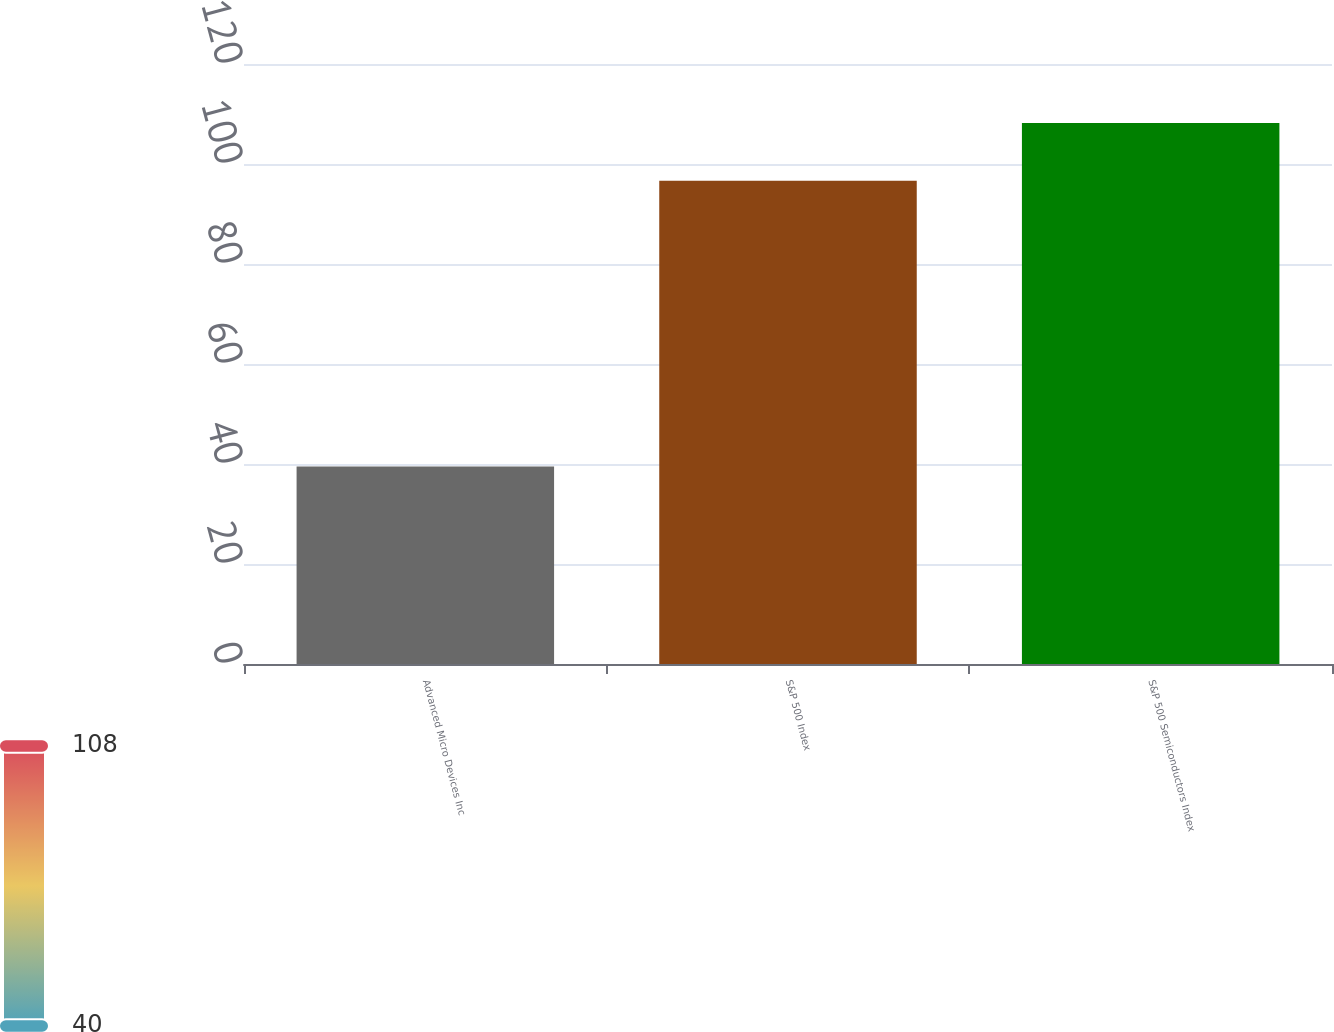Convert chart. <chart><loc_0><loc_0><loc_500><loc_500><bar_chart><fcel>Advanced Micro Devices Inc<fcel>S&P 500 Index<fcel>S&P 500 Semiconductors Index<nl><fcel>39.51<fcel>96.64<fcel>108.19<nl></chart> 